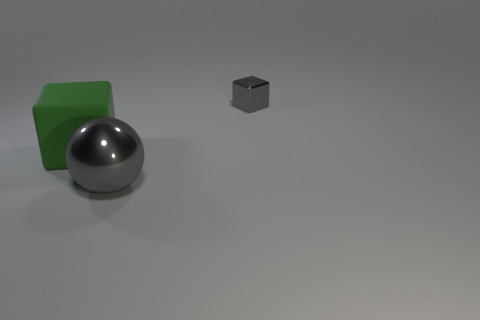Add 3 metallic cubes. How many objects exist? 6 Subtract all balls. How many objects are left? 2 Add 1 gray matte spheres. How many gray matte spheres exist? 1 Subtract 0 red balls. How many objects are left? 3 Subtract all tiny red matte spheres. Subtract all large balls. How many objects are left? 2 Add 1 large blocks. How many large blocks are left? 2 